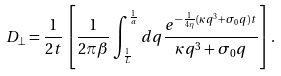Convert formula to latex. <formula><loc_0><loc_0><loc_500><loc_500>D _ { \bot } = \frac { 1 } { 2 t } \left [ \frac { 1 } { 2 \pi \beta } \int _ { \frac { 1 } { L } } ^ { \frac { 1 } { a } } d q \frac { e ^ { - \frac { 1 } { 4 \eta } ( \kappa q ^ { 3 } + \sigma _ { 0 } q ) t } } { \kappa q ^ { 3 } + \sigma _ { 0 } q } \right ] .</formula> 